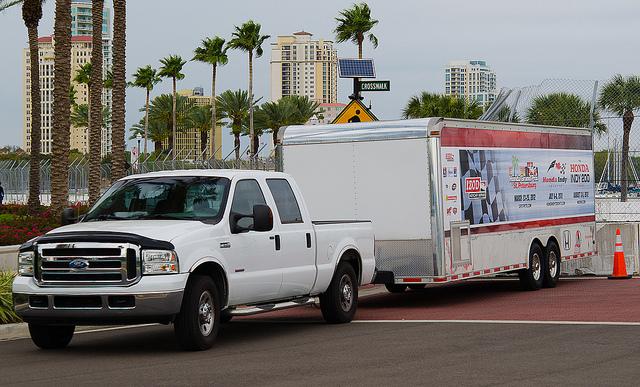Is this truck clean?
Short answer required. Yes. What color is the trailer?
Be succinct. White. What kind of car is on the truck?
Keep it brief. Trailer. Is there traffic?
Quick response, please. No. What is mainly featured?
Concise answer only. Truck. How many orange cones are there?
Be succinct. 1. How many trees are visible?
Concise answer only. 12. Who manufactured the white truck?
Quick response, please. Ford. Is this a modern truck?
Write a very short answer. Yes. 